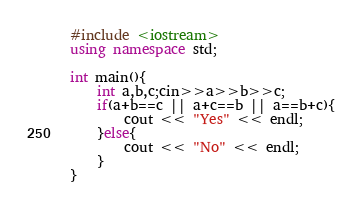Convert code to text. <code><loc_0><loc_0><loc_500><loc_500><_C++_>#include <iostream>
using namespace std;

int main(){
	int a,b,c;cin>>a>>b>>c;
  	if(a+b==c || a+c==b || a==b+c){
    	cout << "Yes" << endl;
    }else{
    	cout << "No" << endl;
    }
}</code> 